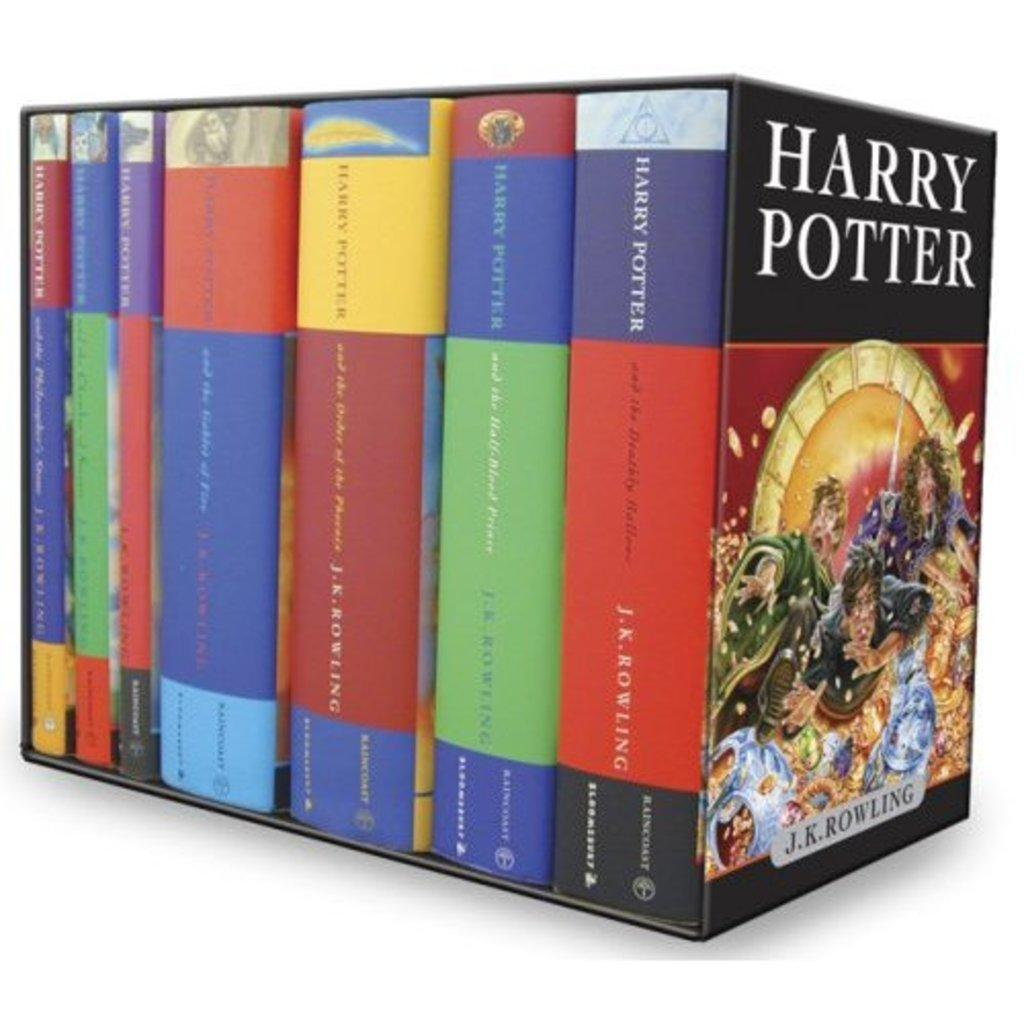<image>
Summarize the visual content of the image. A collection of Harry Potter books by J.K. Rowling is shown on a plain white background. 